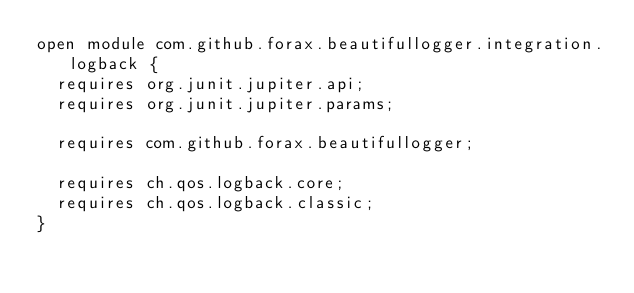<code> <loc_0><loc_0><loc_500><loc_500><_Java_>open module com.github.forax.beautifullogger.integration.logback {
  requires org.junit.jupiter.api;
  requires org.junit.jupiter.params;
  
  requires com.github.forax.beautifullogger;
  
  requires ch.qos.logback.core;
  requires ch.qos.logback.classic;
}
</code> 